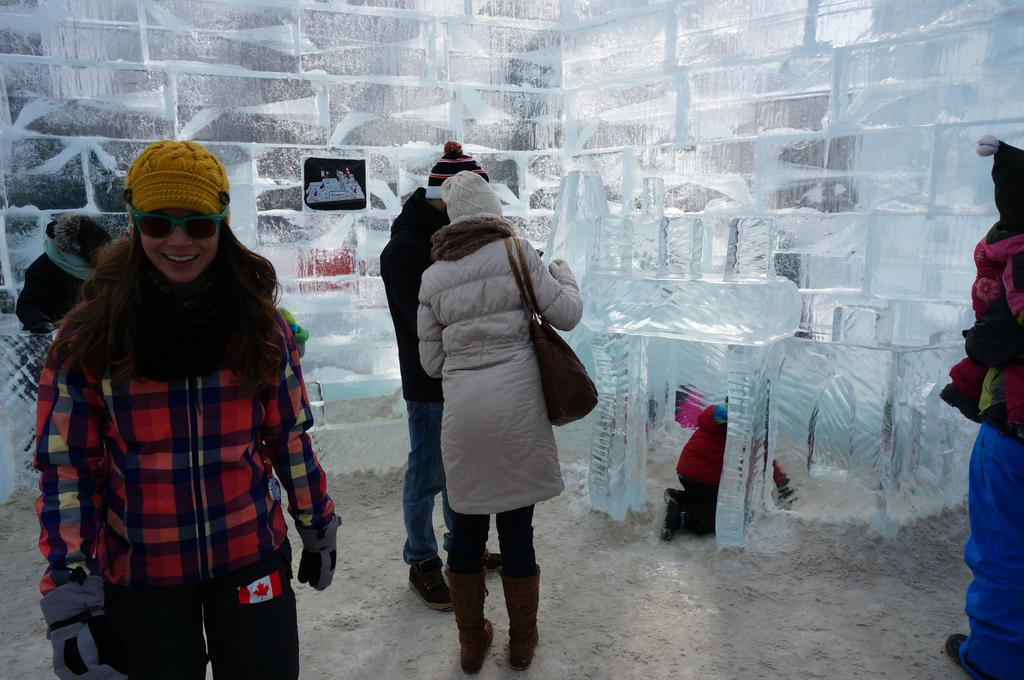What is the setting of the image? The image is set inside an ice room. What are the people in the image doing? The people are visiting the construction in the ice room. Can you describe the activity of the kid in the image? A kid is playing inside a small ice room. What type of clothing are the people wearing in the image? All the people in the image are wearing jackets. How many tickets are visible in the image? There are no tickets present in the image. What type of cup is being used by the people in the image? There is no cup visible in the image. 